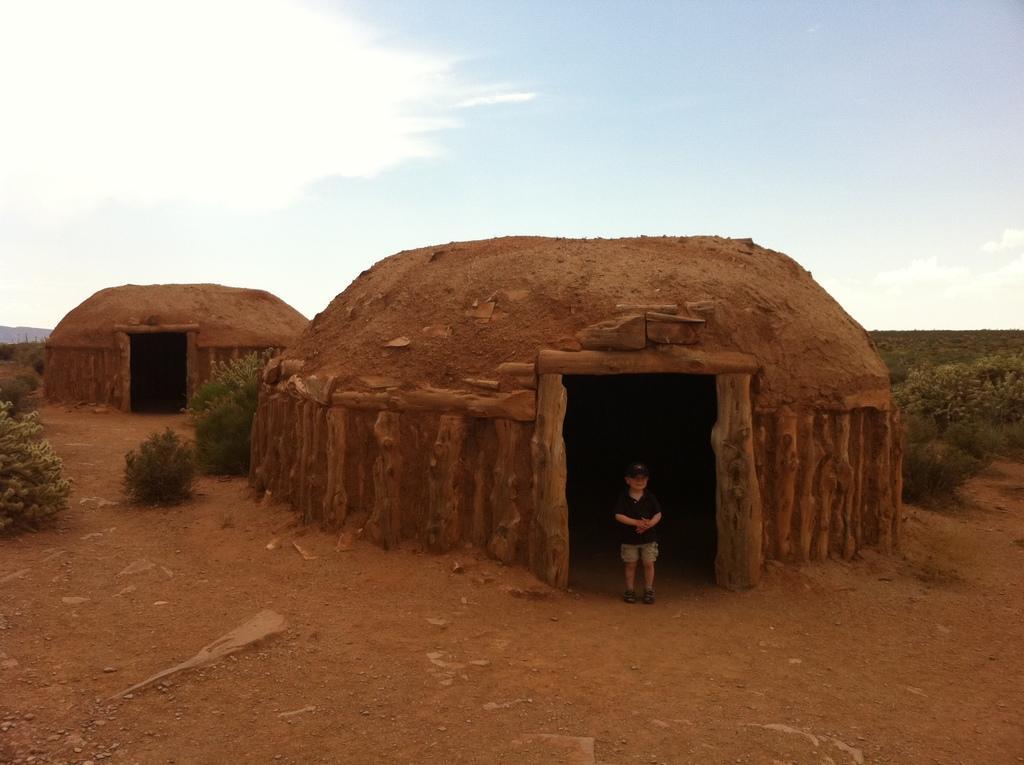Can you describe this image briefly? In this picture we can see small boy is standing in the front of the ground. Behind there is a mud igloo and some plants. On the top there is a sky and clouds. 